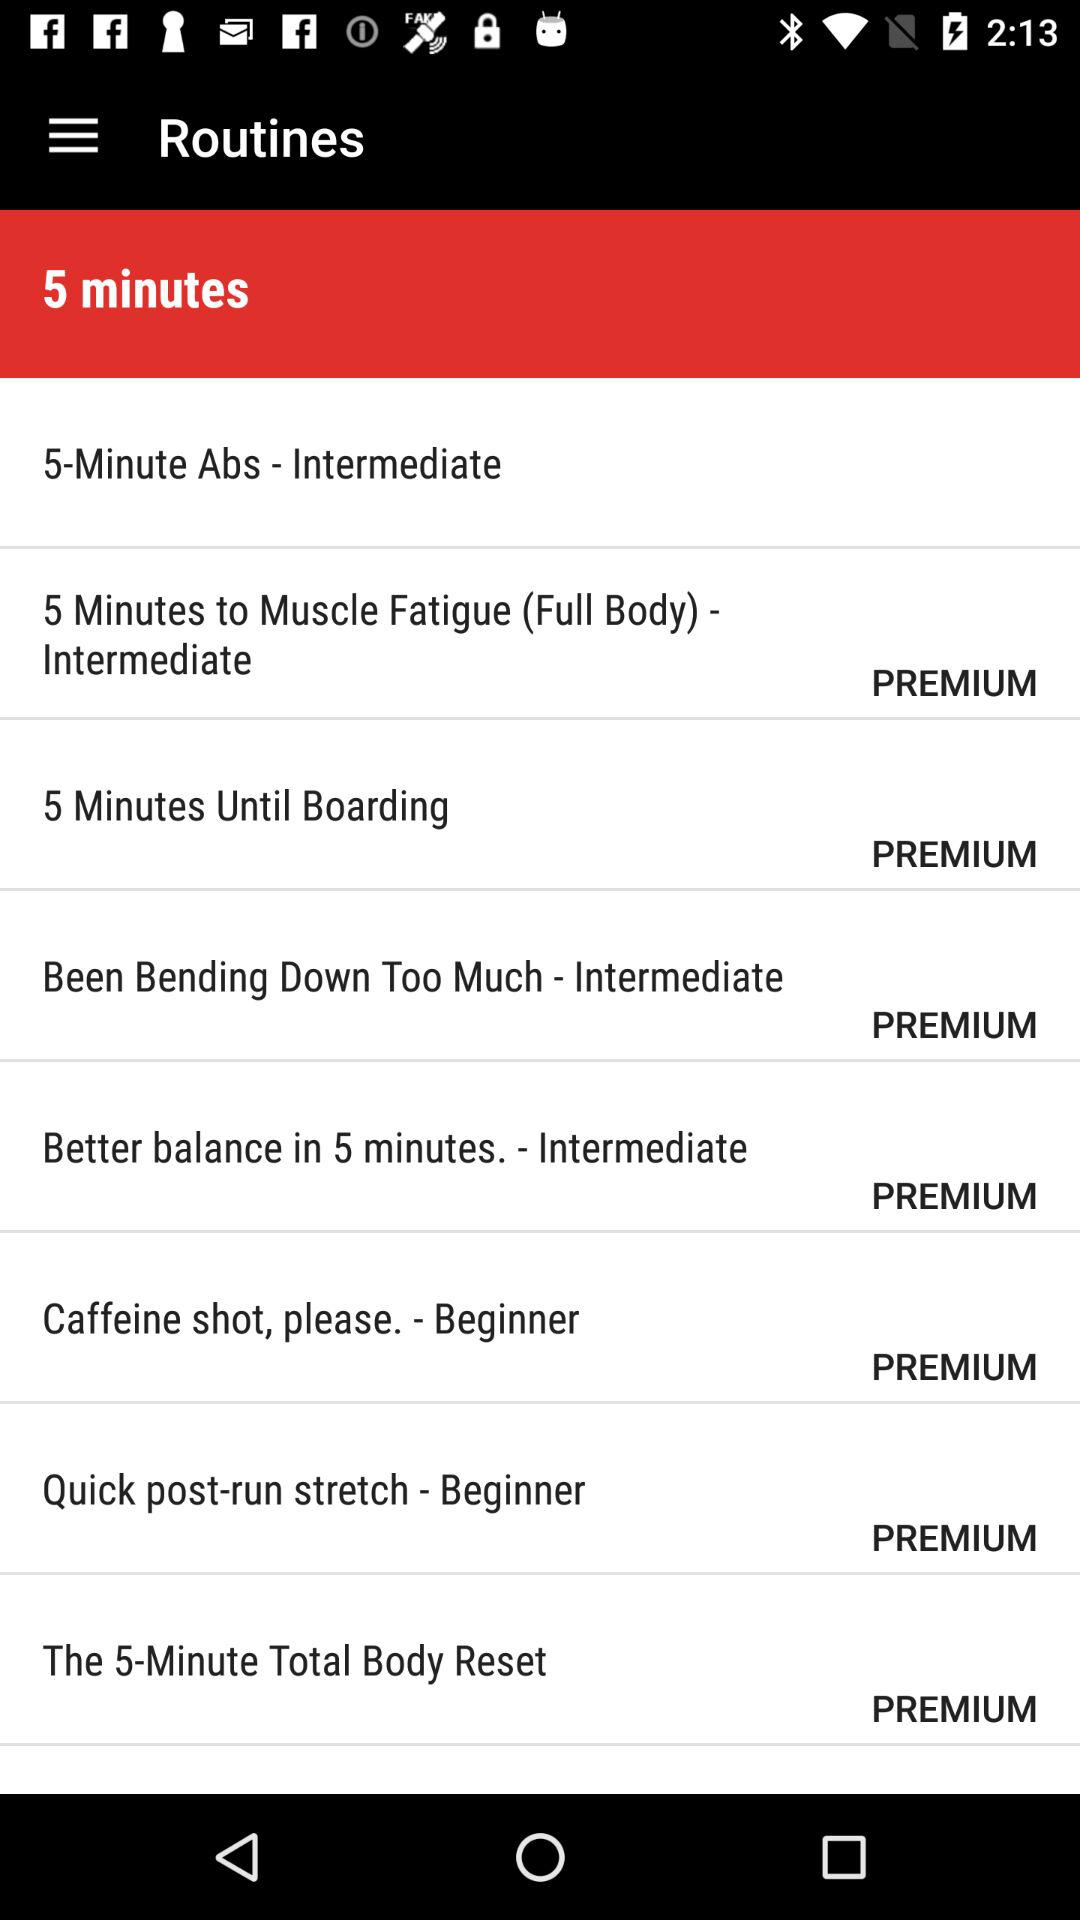Which is the level of "Quick post-run stretch"? The level of "Quick post-run stretch" is "Beginner". 